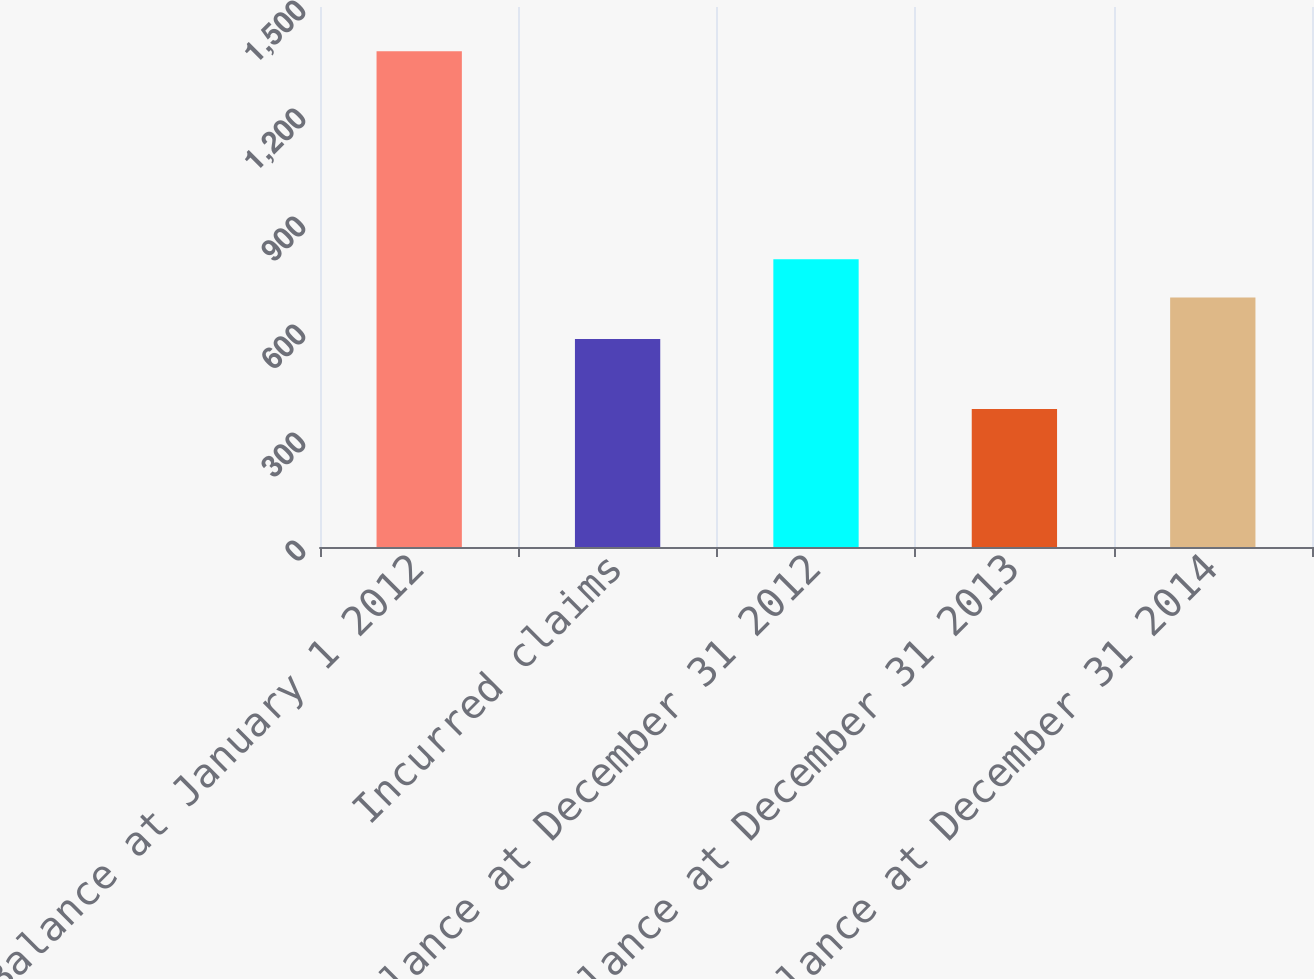<chart> <loc_0><loc_0><loc_500><loc_500><bar_chart><fcel>Balance at January 1 2012<fcel>Incurred claims<fcel>Balance at December 31 2012<fcel>Balance at December 31 2013<fcel>Balance at December 31 2014<nl><fcel>1377<fcel>578<fcel>799<fcel>383<fcel>693<nl></chart> 